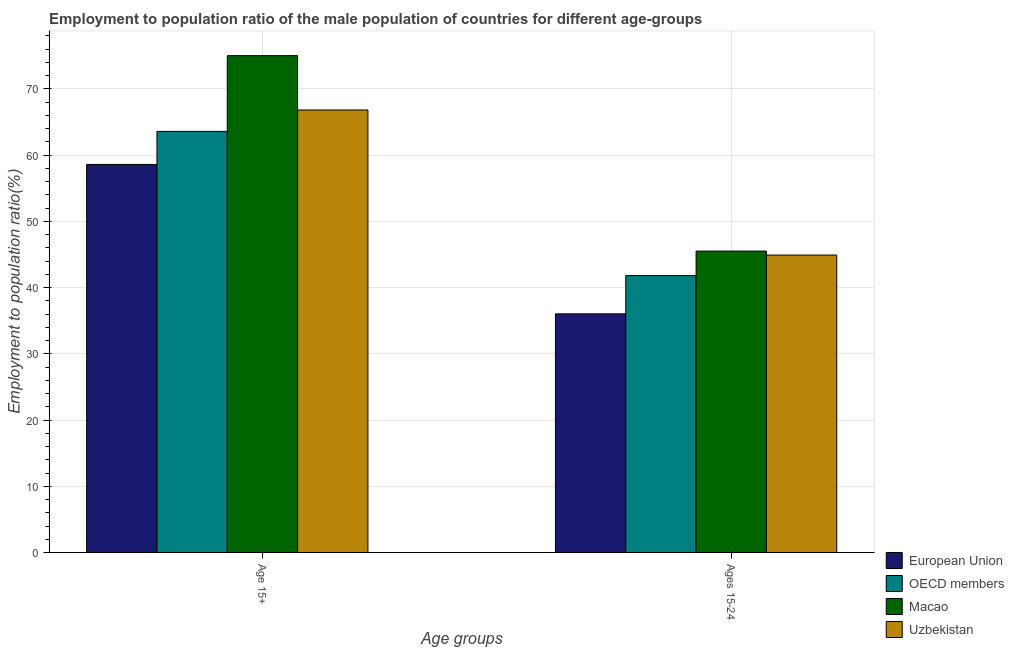Are the number of bars per tick equal to the number of legend labels?
Give a very brief answer. Yes. Are the number of bars on each tick of the X-axis equal?
Keep it short and to the point. Yes. How many bars are there on the 1st tick from the left?
Make the answer very short. 4. How many bars are there on the 2nd tick from the right?
Keep it short and to the point. 4. What is the label of the 2nd group of bars from the left?
Make the answer very short. Ages 15-24. What is the employment to population ratio(age 15+) in European Union?
Ensure brevity in your answer.  58.58. Across all countries, what is the maximum employment to population ratio(age 15-24)?
Offer a very short reply. 45.5. Across all countries, what is the minimum employment to population ratio(age 15-24)?
Provide a succinct answer. 36.03. In which country was the employment to population ratio(age 15+) maximum?
Ensure brevity in your answer.  Macao. What is the total employment to population ratio(age 15+) in the graph?
Your response must be concise. 263.95. What is the difference between the employment to population ratio(age 15+) in European Union and that in Uzbekistan?
Ensure brevity in your answer.  -8.22. What is the difference between the employment to population ratio(age 15-24) in Macao and the employment to population ratio(age 15+) in Uzbekistan?
Provide a short and direct response. -21.3. What is the average employment to population ratio(age 15-24) per country?
Your answer should be compact. 42.06. What is the difference between the employment to population ratio(age 15+) and employment to population ratio(age 15-24) in Macao?
Provide a succinct answer. 29.5. In how many countries, is the employment to population ratio(age 15+) greater than 2 %?
Your answer should be very brief. 4. What is the ratio of the employment to population ratio(age 15-24) in OECD members to that in Macao?
Provide a succinct answer. 0.92. In how many countries, is the employment to population ratio(age 15-24) greater than the average employment to population ratio(age 15-24) taken over all countries?
Ensure brevity in your answer.  2. What does the 4th bar from the left in Age 15+ represents?
Provide a short and direct response. Uzbekistan. Are all the bars in the graph horizontal?
Provide a short and direct response. No. What is the difference between two consecutive major ticks on the Y-axis?
Make the answer very short. 10. Are the values on the major ticks of Y-axis written in scientific E-notation?
Make the answer very short. No. How many legend labels are there?
Your response must be concise. 4. How are the legend labels stacked?
Your answer should be compact. Vertical. What is the title of the graph?
Provide a succinct answer. Employment to population ratio of the male population of countries for different age-groups. Does "Barbados" appear as one of the legend labels in the graph?
Provide a succinct answer. No. What is the label or title of the X-axis?
Your answer should be compact. Age groups. What is the Employment to population ratio(%) in European Union in Age 15+?
Give a very brief answer. 58.58. What is the Employment to population ratio(%) in OECD members in Age 15+?
Provide a short and direct response. 63.57. What is the Employment to population ratio(%) in Uzbekistan in Age 15+?
Keep it short and to the point. 66.8. What is the Employment to population ratio(%) of European Union in Ages 15-24?
Your answer should be compact. 36.03. What is the Employment to population ratio(%) of OECD members in Ages 15-24?
Give a very brief answer. 41.8. What is the Employment to population ratio(%) of Macao in Ages 15-24?
Your answer should be very brief. 45.5. What is the Employment to population ratio(%) of Uzbekistan in Ages 15-24?
Offer a terse response. 44.9. Across all Age groups, what is the maximum Employment to population ratio(%) in European Union?
Offer a terse response. 58.58. Across all Age groups, what is the maximum Employment to population ratio(%) in OECD members?
Offer a very short reply. 63.57. Across all Age groups, what is the maximum Employment to population ratio(%) of Macao?
Offer a very short reply. 75. Across all Age groups, what is the maximum Employment to population ratio(%) in Uzbekistan?
Your answer should be very brief. 66.8. Across all Age groups, what is the minimum Employment to population ratio(%) of European Union?
Provide a succinct answer. 36.03. Across all Age groups, what is the minimum Employment to population ratio(%) in OECD members?
Give a very brief answer. 41.8. Across all Age groups, what is the minimum Employment to population ratio(%) in Macao?
Keep it short and to the point. 45.5. Across all Age groups, what is the minimum Employment to population ratio(%) in Uzbekistan?
Give a very brief answer. 44.9. What is the total Employment to population ratio(%) in European Union in the graph?
Keep it short and to the point. 94.61. What is the total Employment to population ratio(%) in OECD members in the graph?
Offer a terse response. 105.37. What is the total Employment to population ratio(%) of Macao in the graph?
Offer a terse response. 120.5. What is the total Employment to population ratio(%) in Uzbekistan in the graph?
Provide a short and direct response. 111.7. What is the difference between the Employment to population ratio(%) of European Union in Age 15+ and that in Ages 15-24?
Your response must be concise. 22.55. What is the difference between the Employment to population ratio(%) of OECD members in Age 15+ and that in Ages 15-24?
Give a very brief answer. 21.77. What is the difference between the Employment to population ratio(%) in Macao in Age 15+ and that in Ages 15-24?
Give a very brief answer. 29.5. What is the difference between the Employment to population ratio(%) of Uzbekistan in Age 15+ and that in Ages 15-24?
Your answer should be compact. 21.9. What is the difference between the Employment to population ratio(%) of European Union in Age 15+ and the Employment to population ratio(%) of OECD members in Ages 15-24?
Provide a short and direct response. 16.78. What is the difference between the Employment to population ratio(%) of European Union in Age 15+ and the Employment to population ratio(%) of Macao in Ages 15-24?
Give a very brief answer. 13.08. What is the difference between the Employment to population ratio(%) in European Union in Age 15+ and the Employment to population ratio(%) in Uzbekistan in Ages 15-24?
Ensure brevity in your answer.  13.68. What is the difference between the Employment to population ratio(%) in OECD members in Age 15+ and the Employment to population ratio(%) in Macao in Ages 15-24?
Your answer should be compact. 18.07. What is the difference between the Employment to population ratio(%) of OECD members in Age 15+ and the Employment to population ratio(%) of Uzbekistan in Ages 15-24?
Your response must be concise. 18.67. What is the difference between the Employment to population ratio(%) of Macao in Age 15+ and the Employment to population ratio(%) of Uzbekistan in Ages 15-24?
Your answer should be very brief. 30.1. What is the average Employment to population ratio(%) in European Union per Age groups?
Make the answer very short. 47.3. What is the average Employment to population ratio(%) in OECD members per Age groups?
Make the answer very short. 52.69. What is the average Employment to population ratio(%) in Macao per Age groups?
Keep it short and to the point. 60.25. What is the average Employment to population ratio(%) of Uzbekistan per Age groups?
Keep it short and to the point. 55.85. What is the difference between the Employment to population ratio(%) in European Union and Employment to population ratio(%) in OECD members in Age 15+?
Your answer should be very brief. -4.99. What is the difference between the Employment to population ratio(%) of European Union and Employment to population ratio(%) of Macao in Age 15+?
Provide a short and direct response. -16.42. What is the difference between the Employment to population ratio(%) in European Union and Employment to population ratio(%) in Uzbekistan in Age 15+?
Make the answer very short. -8.22. What is the difference between the Employment to population ratio(%) of OECD members and Employment to population ratio(%) of Macao in Age 15+?
Offer a terse response. -11.43. What is the difference between the Employment to population ratio(%) in OECD members and Employment to population ratio(%) in Uzbekistan in Age 15+?
Your answer should be very brief. -3.23. What is the difference between the Employment to population ratio(%) in Macao and Employment to population ratio(%) in Uzbekistan in Age 15+?
Give a very brief answer. 8.2. What is the difference between the Employment to population ratio(%) of European Union and Employment to population ratio(%) of OECD members in Ages 15-24?
Offer a terse response. -5.78. What is the difference between the Employment to population ratio(%) of European Union and Employment to population ratio(%) of Macao in Ages 15-24?
Your response must be concise. -9.47. What is the difference between the Employment to population ratio(%) of European Union and Employment to population ratio(%) of Uzbekistan in Ages 15-24?
Offer a very short reply. -8.87. What is the difference between the Employment to population ratio(%) of OECD members and Employment to population ratio(%) of Macao in Ages 15-24?
Your answer should be very brief. -3.7. What is the difference between the Employment to population ratio(%) in OECD members and Employment to population ratio(%) in Uzbekistan in Ages 15-24?
Your answer should be very brief. -3.1. What is the difference between the Employment to population ratio(%) in Macao and Employment to population ratio(%) in Uzbekistan in Ages 15-24?
Provide a succinct answer. 0.6. What is the ratio of the Employment to population ratio(%) of European Union in Age 15+ to that in Ages 15-24?
Your answer should be compact. 1.63. What is the ratio of the Employment to population ratio(%) in OECD members in Age 15+ to that in Ages 15-24?
Ensure brevity in your answer.  1.52. What is the ratio of the Employment to population ratio(%) of Macao in Age 15+ to that in Ages 15-24?
Provide a succinct answer. 1.65. What is the ratio of the Employment to population ratio(%) of Uzbekistan in Age 15+ to that in Ages 15-24?
Ensure brevity in your answer.  1.49. What is the difference between the highest and the second highest Employment to population ratio(%) in European Union?
Offer a terse response. 22.55. What is the difference between the highest and the second highest Employment to population ratio(%) of OECD members?
Make the answer very short. 21.77. What is the difference between the highest and the second highest Employment to population ratio(%) of Macao?
Offer a terse response. 29.5. What is the difference between the highest and the second highest Employment to population ratio(%) in Uzbekistan?
Your answer should be compact. 21.9. What is the difference between the highest and the lowest Employment to population ratio(%) of European Union?
Your response must be concise. 22.55. What is the difference between the highest and the lowest Employment to population ratio(%) in OECD members?
Provide a succinct answer. 21.77. What is the difference between the highest and the lowest Employment to population ratio(%) of Macao?
Ensure brevity in your answer.  29.5. What is the difference between the highest and the lowest Employment to population ratio(%) in Uzbekistan?
Offer a terse response. 21.9. 